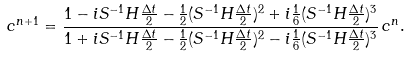Convert formula to latex. <formula><loc_0><loc_0><loc_500><loc_500>c ^ { n + 1 } = \frac { 1 - i S ^ { - 1 } H \frac { \Delta t } { 2 } - \frac { 1 } { 2 } ( S ^ { - 1 } H \frac { \Delta t } { 2 } ) ^ { 2 } + i \frac { 1 } { 6 } ( S ^ { - 1 } H \frac { \Delta t } { 2 } ) ^ { 3 } } { 1 + i S ^ { - 1 } H \frac { \Delta t } { 2 } - \frac { 1 } { 2 } ( S ^ { - 1 } H \frac { \Delta t } { 2 } ) ^ { 2 } - i \frac { 1 } { 6 } ( S ^ { - 1 } H \frac { \Delta t } { 2 } ) ^ { 3 } } \, c ^ { n } .</formula> 